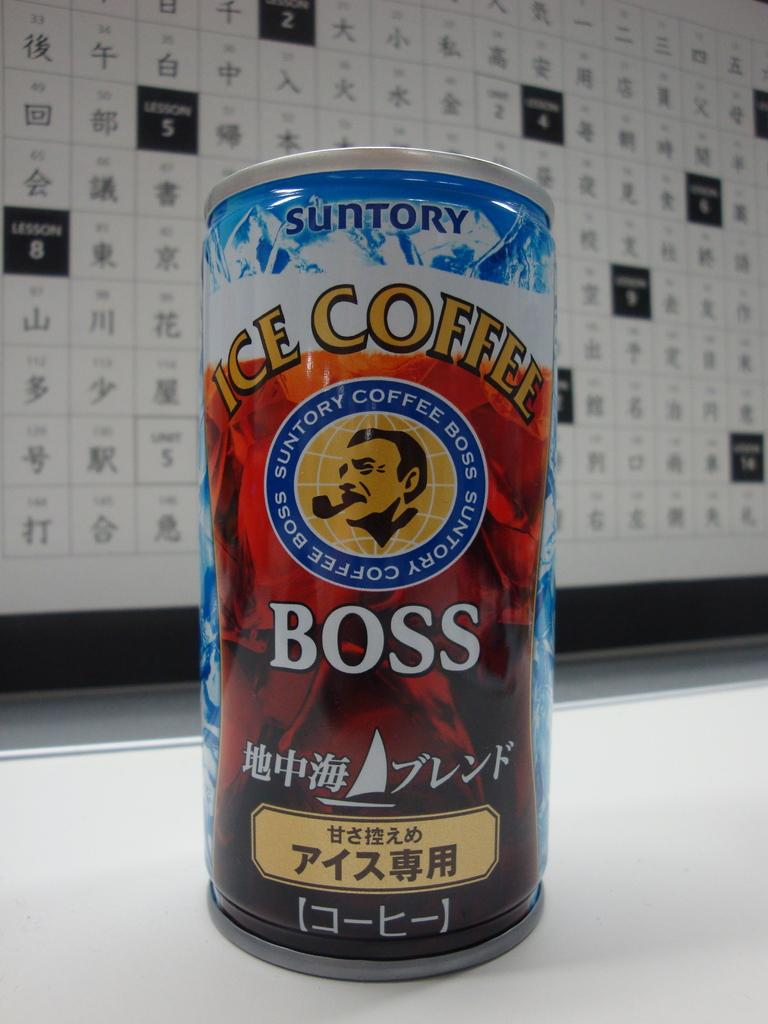<image>
Create a compact narrative representing the image presented. The Boss Suntory ice coffee can has a round emblem in the middle with a man and pipe in it. 